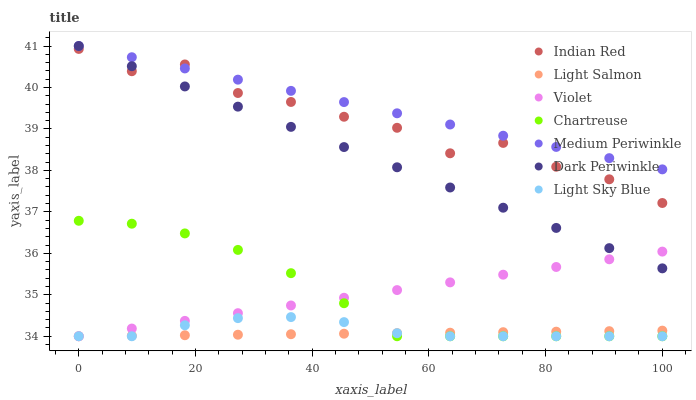Does Light Salmon have the minimum area under the curve?
Answer yes or no. Yes. Does Medium Periwinkle have the maximum area under the curve?
Answer yes or no. Yes. Does Chartreuse have the minimum area under the curve?
Answer yes or no. No. Does Chartreuse have the maximum area under the curve?
Answer yes or no. No. Is Dark Periwinkle the smoothest?
Answer yes or no. Yes. Is Indian Red the roughest?
Answer yes or no. Yes. Is Medium Periwinkle the smoothest?
Answer yes or no. No. Is Medium Periwinkle the roughest?
Answer yes or no. No. Does Light Salmon have the lowest value?
Answer yes or no. Yes. Does Medium Periwinkle have the lowest value?
Answer yes or no. No. Does Dark Periwinkle have the highest value?
Answer yes or no. Yes. Does Chartreuse have the highest value?
Answer yes or no. No. Is Light Salmon less than Dark Periwinkle?
Answer yes or no. Yes. Is Medium Periwinkle greater than Light Salmon?
Answer yes or no. Yes. Does Violet intersect Dark Periwinkle?
Answer yes or no. Yes. Is Violet less than Dark Periwinkle?
Answer yes or no. No. Is Violet greater than Dark Periwinkle?
Answer yes or no. No. Does Light Salmon intersect Dark Periwinkle?
Answer yes or no. No. 